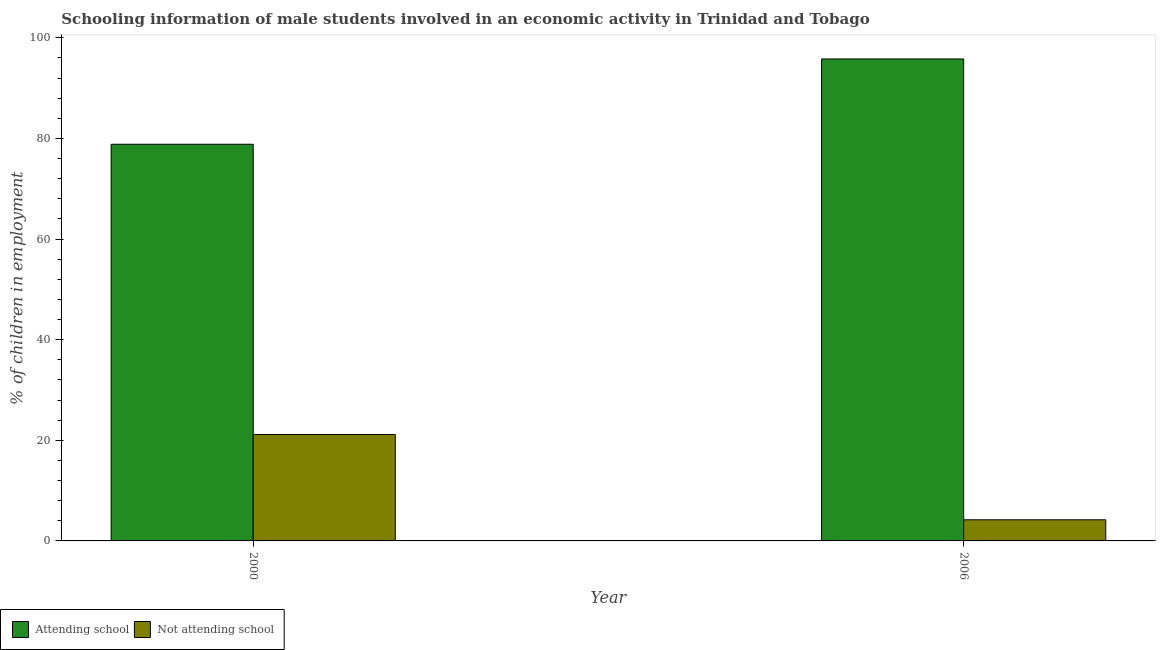How many different coloured bars are there?
Your answer should be compact. 2. Are the number of bars on each tick of the X-axis equal?
Your answer should be very brief. Yes. What is the label of the 1st group of bars from the left?
Make the answer very short. 2000. What is the percentage of employed males who are not attending school in 2006?
Make the answer very short. 4.2. Across all years, what is the maximum percentage of employed males who are not attending school?
Your response must be concise. 21.15. Across all years, what is the minimum percentage of employed males who are attending school?
Offer a very short reply. 78.85. What is the total percentage of employed males who are not attending school in the graph?
Give a very brief answer. 25.35. What is the difference between the percentage of employed males who are attending school in 2000 and that in 2006?
Your answer should be compact. -16.95. What is the difference between the percentage of employed males who are not attending school in 2006 and the percentage of employed males who are attending school in 2000?
Offer a very short reply. -16.95. What is the average percentage of employed males who are attending school per year?
Provide a succinct answer. 87.32. In how many years, is the percentage of employed males who are attending school greater than 96 %?
Your answer should be compact. 0. What is the ratio of the percentage of employed males who are not attending school in 2000 to that in 2006?
Offer a terse response. 5.04. Is the percentage of employed males who are not attending school in 2000 less than that in 2006?
Your response must be concise. No. What does the 1st bar from the left in 2006 represents?
Your answer should be very brief. Attending school. What does the 2nd bar from the right in 2006 represents?
Make the answer very short. Attending school. How many bars are there?
Your answer should be compact. 4. Are all the bars in the graph horizontal?
Ensure brevity in your answer.  No. How many years are there in the graph?
Make the answer very short. 2. What is the difference between two consecutive major ticks on the Y-axis?
Provide a short and direct response. 20. Are the values on the major ticks of Y-axis written in scientific E-notation?
Provide a short and direct response. No. Does the graph contain grids?
Offer a terse response. No. What is the title of the graph?
Keep it short and to the point. Schooling information of male students involved in an economic activity in Trinidad and Tobago. What is the label or title of the Y-axis?
Your answer should be compact. % of children in employment. What is the % of children in employment of Attending school in 2000?
Your response must be concise. 78.85. What is the % of children in employment in Not attending school in 2000?
Provide a short and direct response. 21.15. What is the % of children in employment of Attending school in 2006?
Offer a very short reply. 95.8. Across all years, what is the maximum % of children in employment in Attending school?
Ensure brevity in your answer.  95.8. Across all years, what is the maximum % of children in employment in Not attending school?
Give a very brief answer. 21.15. Across all years, what is the minimum % of children in employment of Attending school?
Provide a short and direct response. 78.85. Across all years, what is the minimum % of children in employment of Not attending school?
Provide a succinct answer. 4.2. What is the total % of children in employment of Attending school in the graph?
Make the answer very short. 174.65. What is the total % of children in employment of Not attending school in the graph?
Offer a very short reply. 25.35. What is the difference between the % of children in employment in Attending school in 2000 and that in 2006?
Ensure brevity in your answer.  -16.95. What is the difference between the % of children in employment of Not attending school in 2000 and that in 2006?
Your answer should be very brief. 16.95. What is the difference between the % of children in employment of Attending school in 2000 and the % of children in employment of Not attending school in 2006?
Your answer should be compact. 74.65. What is the average % of children in employment of Attending school per year?
Give a very brief answer. 87.32. What is the average % of children in employment in Not attending school per year?
Give a very brief answer. 12.68. In the year 2000, what is the difference between the % of children in employment of Attending school and % of children in employment of Not attending school?
Give a very brief answer. 57.69. In the year 2006, what is the difference between the % of children in employment of Attending school and % of children in employment of Not attending school?
Keep it short and to the point. 91.6. What is the ratio of the % of children in employment of Attending school in 2000 to that in 2006?
Offer a very short reply. 0.82. What is the ratio of the % of children in employment of Not attending school in 2000 to that in 2006?
Your answer should be compact. 5.04. What is the difference between the highest and the second highest % of children in employment in Attending school?
Offer a very short reply. 16.95. What is the difference between the highest and the second highest % of children in employment of Not attending school?
Give a very brief answer. 16.95. What is the difference between the highest and the lowest % of children in employment in Attending school?
Your response must be concise. 16.95. What is the difference between the highest and the lowest % of children in employment in Not attending school?
Make the answer very short. 16.95. 